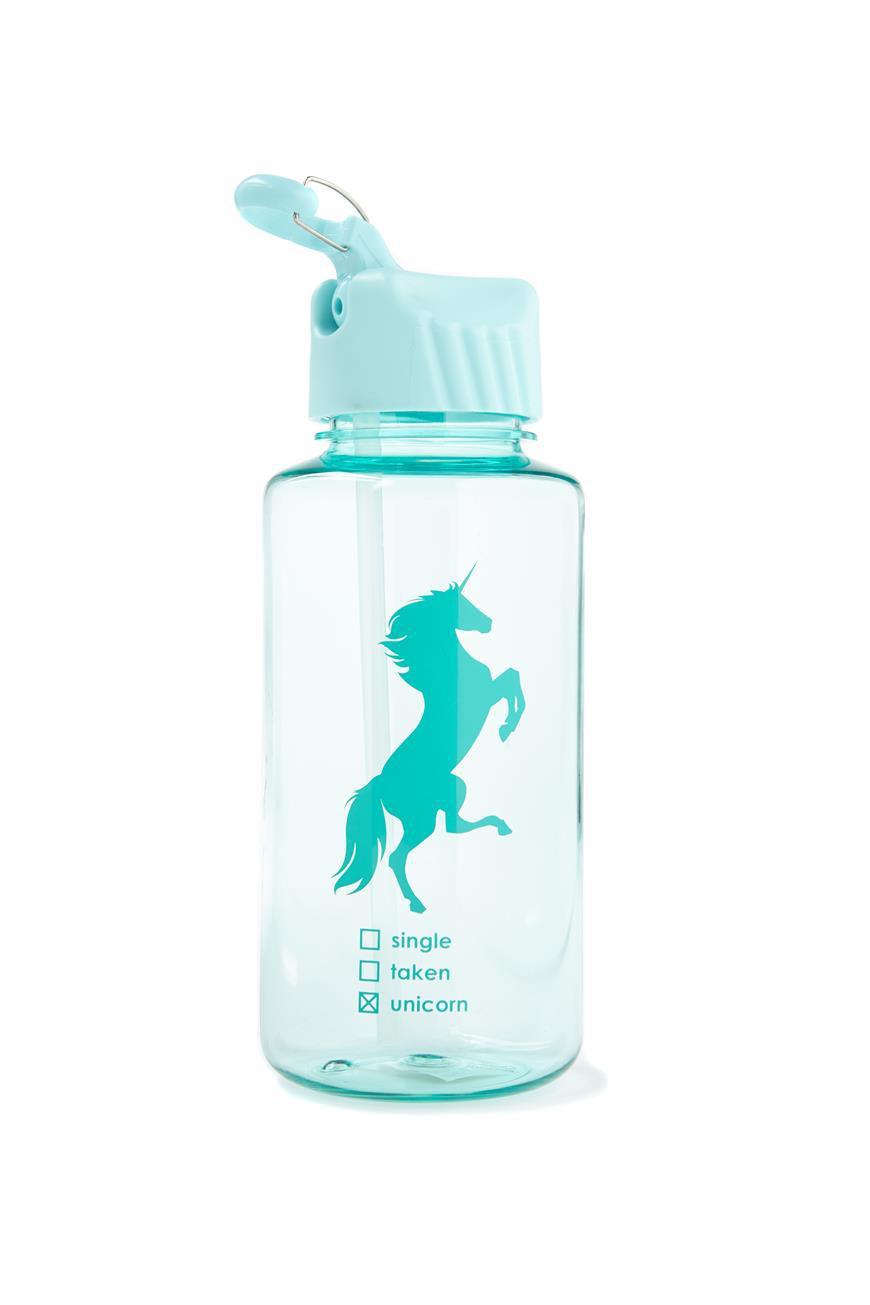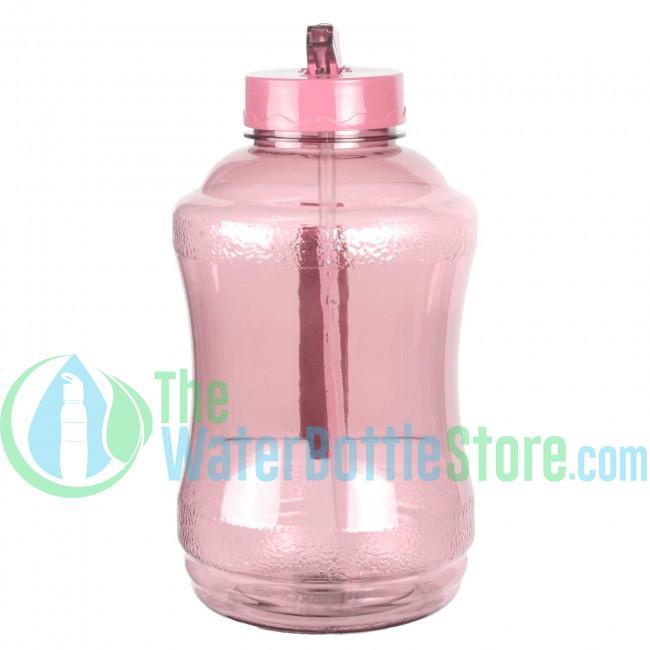The first image is the image on the left, the second image is the image on the right. Considering the images on both sides, is "Each image shows a bottle shaped like a cylinder with straight sides, and the water bottle on the right is pink with a pattern of small black ovals and has a green cap with a loop on the right." valid? Answer yes or no. No. 